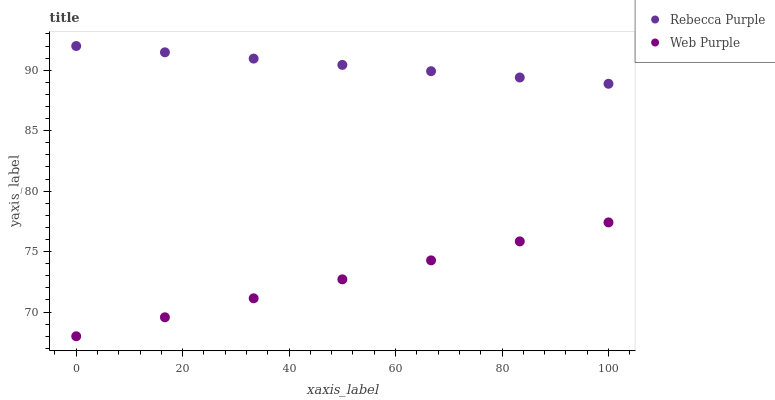Does Web Purple have the minimum area under the curve?
Answer yes or no. Yes. Does Rebecca Purple have the maximum area under the curve?
Answer yes or no. Yes. Does Rebecca Purple have the minimum area under the curve?
Answer yes or no. No. Is Web Purple the smoothest?
Answer yes or no. Yes. Is Rebecca Purple the roughest?
Answer yes or no. Yes. Is Rebecca Purple the smoothest?
Answer yes or no. No. Does Web Purple have the lowest value?
Answer yes or no. Yes. Does Rebecca Purple have the lowest value?
Answer yes or no. No. Does Rebecca Purple have the highest value?
Answer yes or no. Yes. Is Web Purple less than Rebecca Purple?
Answer yes or no. Yes. Is Rebecca Purple greater than Web Purple?
Answer yes or no. Yes. Does Web Purple intersect Rebecca Purple?
Answer yes or no. No. 